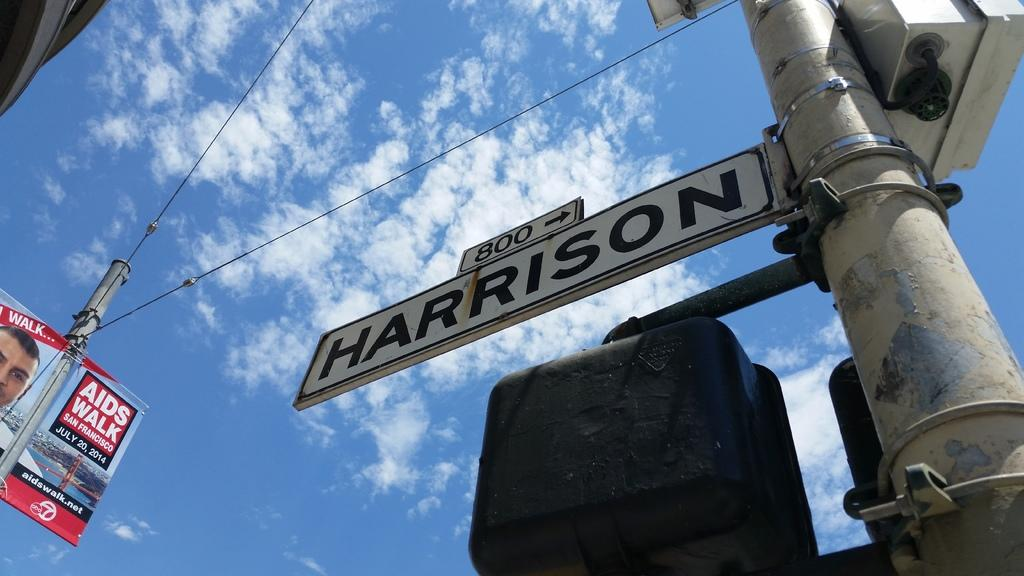<image>
Render a clear and concise summary of the photo. Harrison street sits near an ad for Aids Walk 